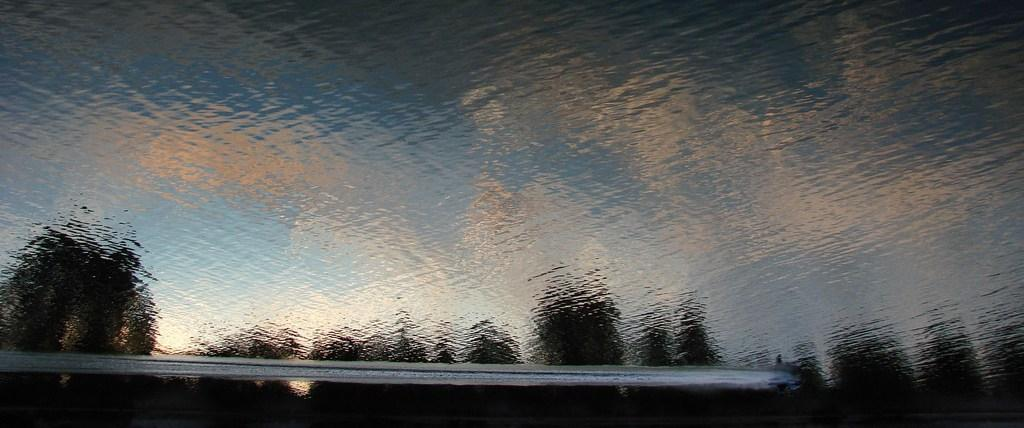What object can be seen in the image that is typically used for holding liquids? There is a glass in the image in the image that is typically used for holding liquids. What part of the natural environment is visible in the image? The sky and trees are visible in the image. What type of fowl can be seen sitting on the button in the image? There is no fowl or button present in the image. What is the root of the tree in the image? There is no root visible in the image, as only the sky and trees are mentioned. 